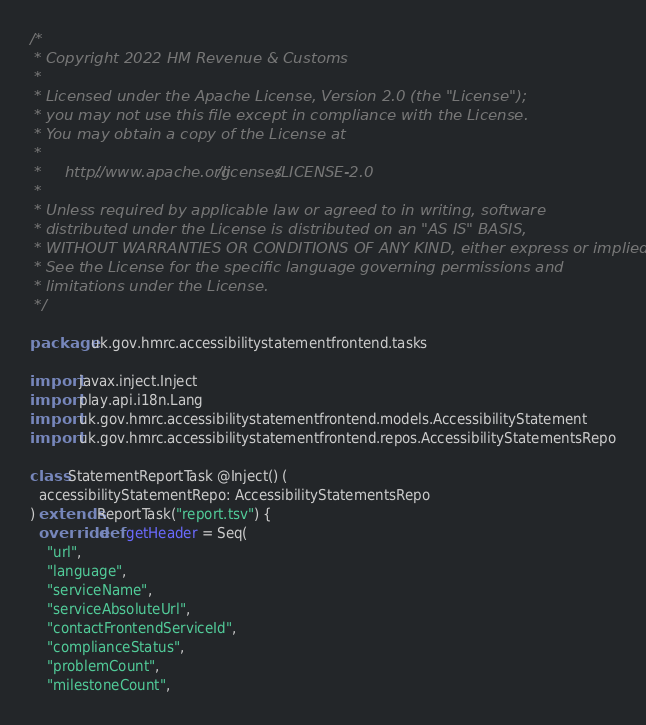<code> <loc_0><loc_0><loc_500><loc_500><_Scala_>/*
 * Copyright 2022 HM Revenue & Customs
 *
 * Licensed under the Apache License, Version 2.0 (the "License");
 * you may not use this file except in compliance with the License.
 * You may obtain a copy of the License at
 *
 *     http://www.apache.org/licenses/LICENSE-2.0
 *
 * Unless required by applicable law or agreed to in writing, software
 * distributed under the License is distributed on an "AS IS" BASIS,
 * WITHOUT WARRANTIES OR CONDITIONS OF ANY KIND, either express or implied.
 * See the License for the specific language governing permissions and
 * limitations under the License.
 */

package uk.gov.hmrc.accessibilitystatementfrontend.tasks

import javax.inject.Inject
import play.api.i18n.Lang
import uk.gov.hmrc.accessibilitystatementfrontend.models.AccessibilityStatement
import uk.gov.hmrc.accessibilitystatementfrontend.repos.AccessibilityStatementsRepo

class StatementReportTask @Inject() (
  accessibilityStatementRepo: AccessibilityStatementsRepo
) extends ReportTask("report.tsv") {
  override def getHeader = Seq(
    "url",
    "language",
    "serviceName",
    "serviceAbsoluteUrl",
    "contactFrontendServiceId",
    "complianceStatus",
    "problemCount",
    "milestoneCount",</code> 